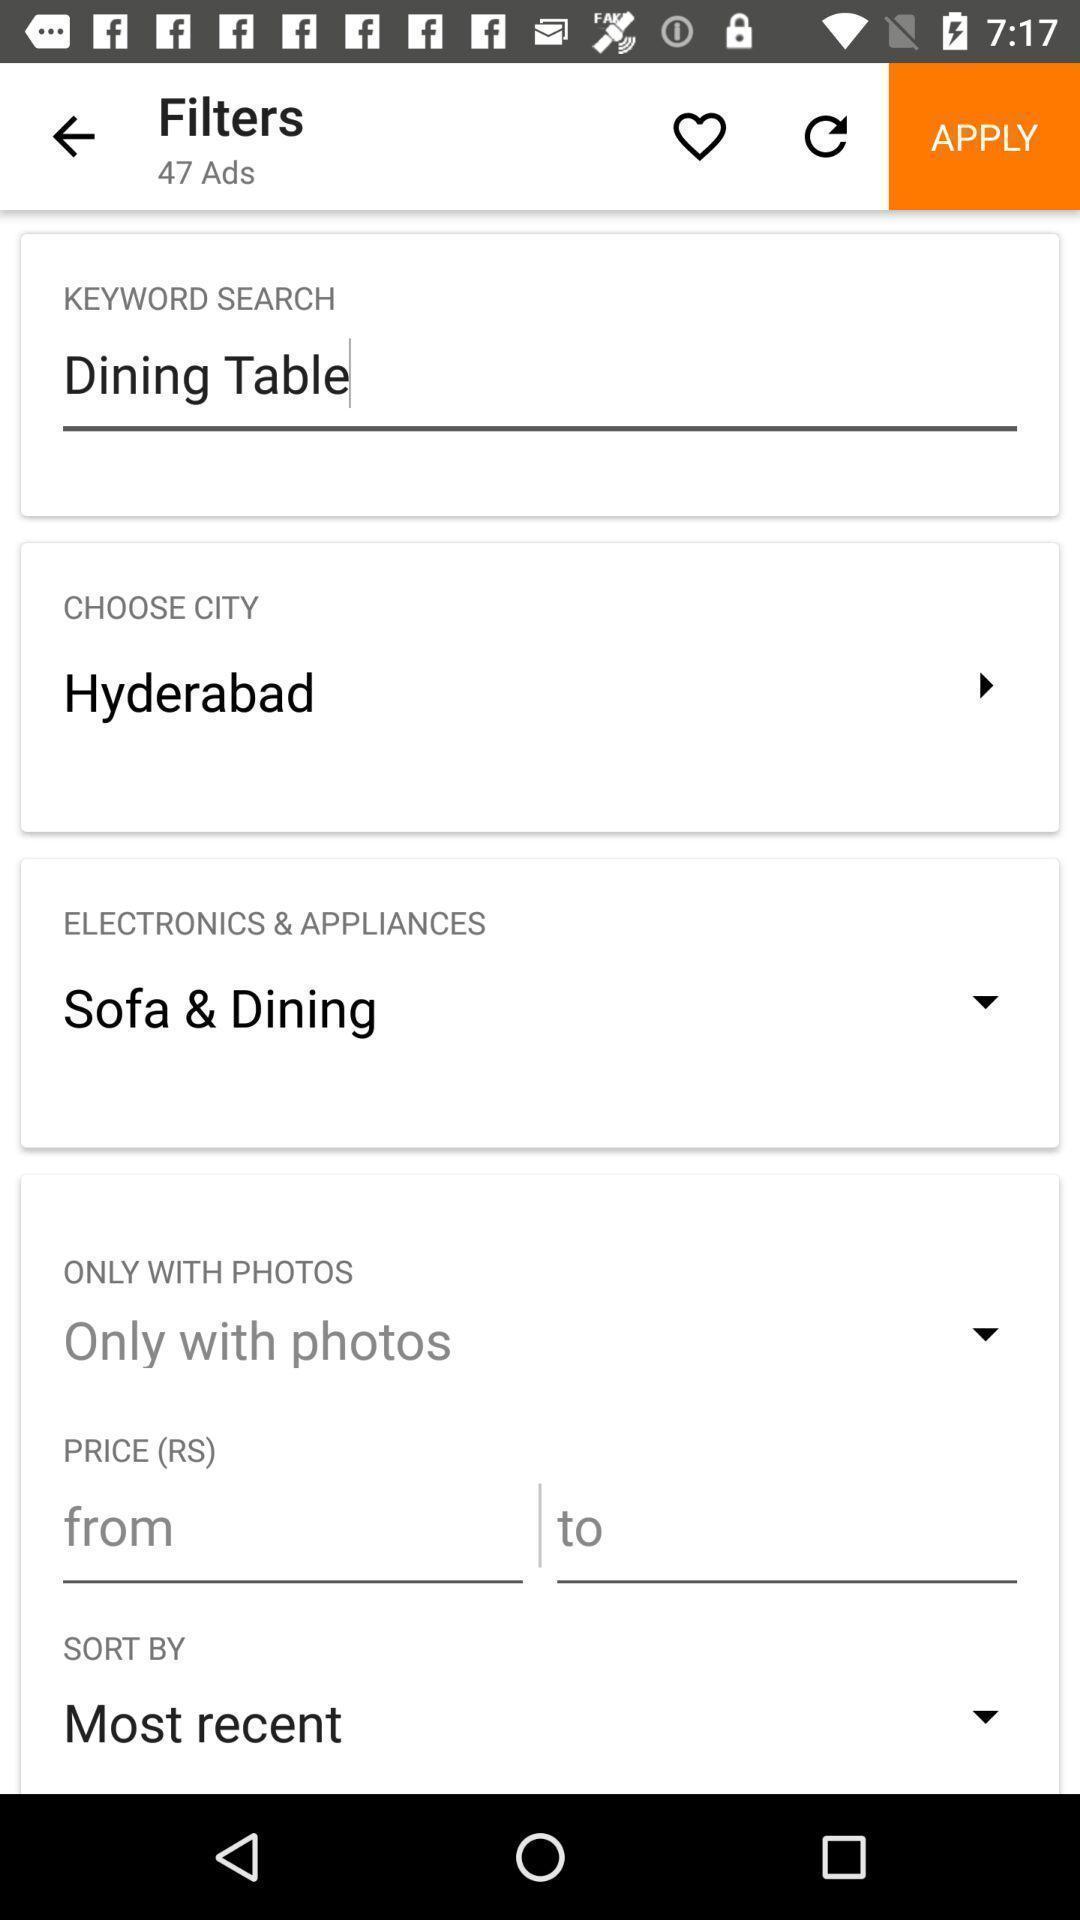Provide a description of this screenshot. Screen shows multiple details in a shopping application. 